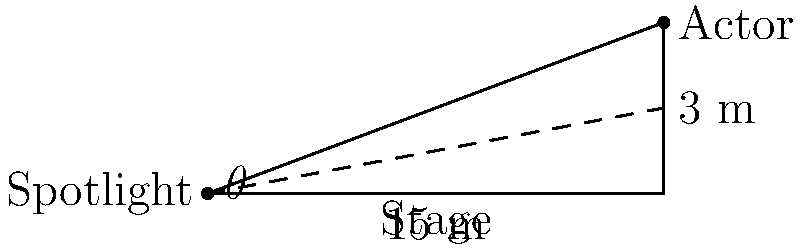As a seasoned character actor, you're preparing for a pivotal scene where precise lighting is crucial. The spotlight operator needs to know the angle of elevation to properly illuminate you on stage. If the spotlight is positioned at the edge of the stage, 15 meters away from your position, and you're standing 3 meters above stage level, what is the angle of elevation ($\theta$) the spotlight operator should use? To solve this problem, we'll use trigonometry, specifically the tangent function. Let's approach this step-by-step:

1) We have a right triangle where:
   - The adjacent side (distance along the stage) is 15 meters
   - The opposite side (height difference) is 3 meters
   - We need to find the angle $\theta$

2) The tangent of an angle in a right triangle is defined as the ratio of the opposite side to the adjacent side:

   $\tan(\theta) = \frac{\text{opposite}}{\text{adjacent}}$

3) Substituting our values:

   $\tan(\theta) = \frac{3}{15}$

4) Simplify the fraction:

   $\tan(\theta) = \frac{1}{5} = 0.2$

5) To find $\theta$, we need to use the inverse tangent (arctangent) function:

   $\theta = \tan^{-1}(0.2)$

6) Using a calculator or trigonometric tables:

   $\theta \approx 11.31°$

Therefore, the spotlight operator should set the angle of elevation to approximately 11.31 degrees to properly illuminate you on stage.
Answer: $11.31°$ 